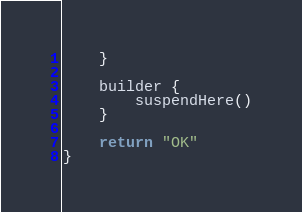Convert code to text. <code><loc_0><loc_0><loc_500><loc_500><_Kotlin_>    }

    builder {
        suspendHere()
    }

    return "OK"
}
</code> 